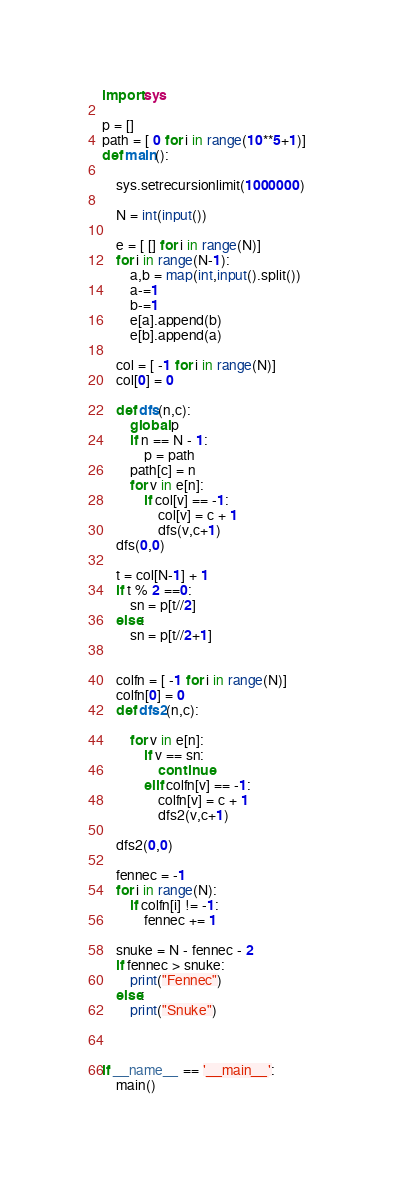Convert code to text. <code><loc_0><loc_0><loc_500><loc_500><_Python_>import sys

p = []
path = [ 0 for i in range(10**5+1)]
def main():

    sys.setrecursionlimit(1000000)

    N = int(input())

    e = [ [] for i in range(N)]
    for i in range(N-1):
        a,b = map(int,input().split())
        a-=1
        b-=1
        e[a].append(b)
        e[b].append(a)

    col = [ -1 for i in range(N)]
    col[0] = 0
    
    def dfs(n,c):
        global p
        if n == N - 1:
            p = path
        path[c] = n
        for v in e[n]:
            if col[v] == -1:
                col[v] = c + 1
                dfs(v,c+1)
    dfs(0,0)

    t = col[N-1] + 1
    if t % 2 ==0:
        sn = p[t//2]
    else:
        sn = p[t//2+1]


    colfn = [ -1 for i in range(N)]
    colfn[0] = 0
    def dfs2(n,c):

        for v in e[n]:
            if v == sn:
                continue
            elif colfn[v] == -1:
                colfn[v] = c + 1
                dfs2(v,c+1)

    dfs2(0,0)

    fennec = -1
    for i in range(N):
        if colfn[i] != -1:
            fennec += 1

    snuke = N - fennec - 2
    if fennec > snuke:
        print("Fennec")
    else:
        print("Snuke")



if __name__ == '__main__':
    main()

</code> 